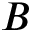<formula> <loc_0><loc_0><loc_500><loc_500>B</formula> 